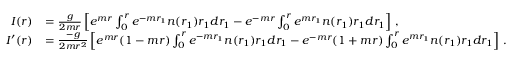Convert formula to latex. <formula><loc_0><loc_0><loc_500><loc_500>\begin{array} { r l } { I ( r ) } & { = \frac { g } 2 m r } \left [ e ^ { m r } \int _ { 0 } ^ { r } e ^ { - m r _ { 1 } } n ( r _ { 1 } ) r _ { 1 } d r _ { 1 } - e ^ { - m r } \int _ { 0 } ^ { r } e ^ { m r _ { 1 } } n ( r _ { 1 } ) r _ { 1 } d r _ { 1 } \right ] \, , } \\ { I ^ { \prime } ( r ) } & { = \frac { - g } { 2 m r ^ { 2 } } \left [ e ^ { m r } ( 1 - m r ) \int _ { 0 } ^ { r } e ^ { - m r _ { 1 } } n ( r _ { 1 } ) r _ { 1 } d r _ { 1 } - e ^ { - m r } ( 1 + m r ) \int _ { 0 } ^ { r } e ^ { m r _ { 1 } } n ( r _ { 1 } ) r _ { 1 } d r _ { 1 } \right ] \, . } \end{array}</formula> 